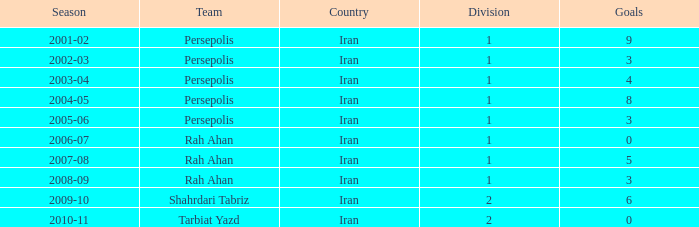When the goals are under 6, what season corresponds to the "tarbiat yazd" team? 2010-11. Would you be able to parse every entry in this table? {'header': ['Season', 'Team', 'Country', 'Division', 'Goals'], 'rows': [['2001-02', 'Persepolis', 'Iran', '1', '9'], ['2002-03', 'Persepolis', 'Iran', '1', '3'], ['2003-04', 'Persepolis', 'Iran', '1', '4'], ['2004-05', 'Persepolis', 'Iran', '1', '8'], ['2005-06', 'Persepolis', 'Iran', '1', '3'], ['2006-07', 'Rah Ahan', 'Iran', '1', '0'], ['2007-08', 'Rah Ahan', 'Iran', '1', '5'], ['2008-09', 'Rah Ahan', 'Iran', '1', '3'], ['2009-10', 'Shahrdari Tabriz', 'Iran', '2', '6'], ['2010-11', 'Tarbiat Yazd', 'Iran', '2', '0']]} 